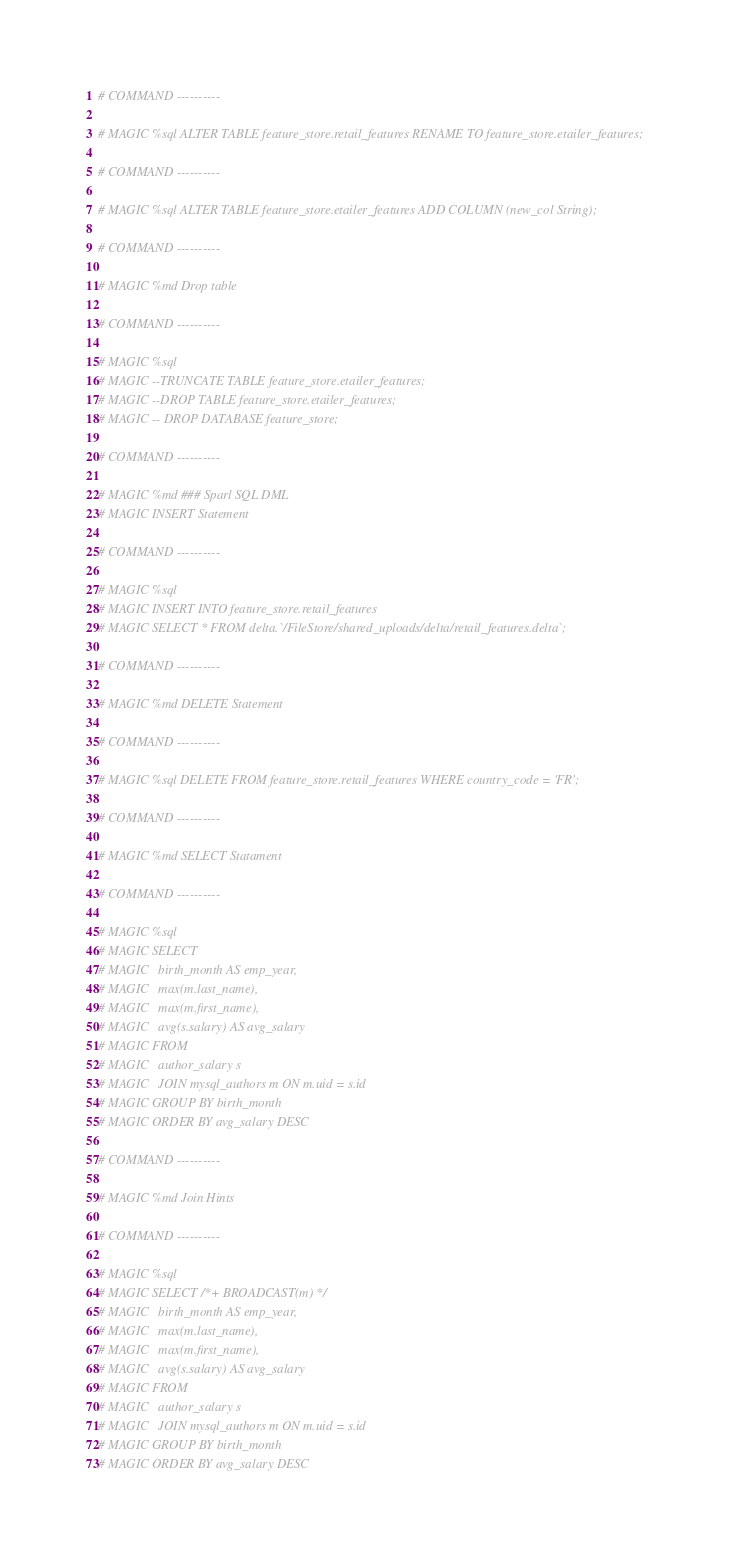<code> <loc_0><loc_0><loc_500><loc_500><_Python_># COMMAND ----------

# MAGIC %sql ALTER TABLE feature_store.retail_features RENAME TO feature_store.etailer_features;

# COMMAND ----------

# MAGIC %sql ALTER TABLE feature_store.etailer_features ADD COLUMN (new_col String);

# COMMAND ----------

# MAGIC %md Drop table

# COMMAND ----------

# MAGIC %sql 
# MAGIC --TRUNCATE TABLE feature_store.etailer_features;
# MAGIC --DROP TABLE feature_store.etailer_features;
# MAGIC -- DROP DATABASE feature_store;

# COMMAND ----------

# MAGIC %md ### Sparl SQL DML
# MAGIC INSERT Statement

# COMMAND ----------

# MAGIC %sql
# MAGIC INSERT INTO feature_store.retail_features
# MAGIC SELECT * FROM delta.`/FileStore/shared_uploads/delta/retail_features.delta`;

# COMMAND ----------

# MAGIC %md DELETE Statement

# COMMAND ----------

# MAGIC %sql DELETE FROM feature_store.retail_features WHERE country_code = 'FR';

# COMMAND ----------

# MAGIC %md SELECT Statament

# COMMAND ----------

# MAGIC %sql
# MAGIC SELECT
# MAGIC   birth_month AS emp_year,
# MAGIC   max(m.last_name),
# MAGIC   max(m.first_name),
# MAGIC   avg(s.salary) AS avg_salary
# MAGIC FROM
# MAGIC   author_salary s
# MAGIC   JOIN mysql_authors m ON m.uid = s.id
# MAGIC GROUP BY birth_month
# MAGIC ORDER BY avg_salary DESC

# COMMAND ----------

# MAGIC %md Join Hints

# COMMAND ----------

# MAGIC %sql
# MAGIC SELECT /*+ BROADCAST(m) */
# MAGIC   birth_month AS emp_year,
# MAGIC   max(m.last_name),
# MAGIC   max(m.first_name),
# MAGIC   avg(s.salary) AS avg_salary
# MAGIC FROM
# MAGIC   author_salary s
# MAGIC   JOIN mysql_authors m ON m.uid = s.id
# MAGIC GROUP BY birth_month
# MAGIC ORDER BY avg_salary DESC</code> 